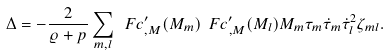Convert formula to latex. <formula><loc_0><loc_0><loc_500><loc_500>\Delta = - \frac { 2 } { \varrho + p } \sum _ { m , l } \ F c _ { , { M } } ^ { \prime } ( { M } _ { m } ) \ F c _ { , { M } } ^ { \prime } ( { M } _ { l } ) { M } _ { m } \tau _ { m } \dot { \tau } _ { m } \dot { \tau } _ { l } ^ { 2 } \zeta _ { m l } .</formula> 